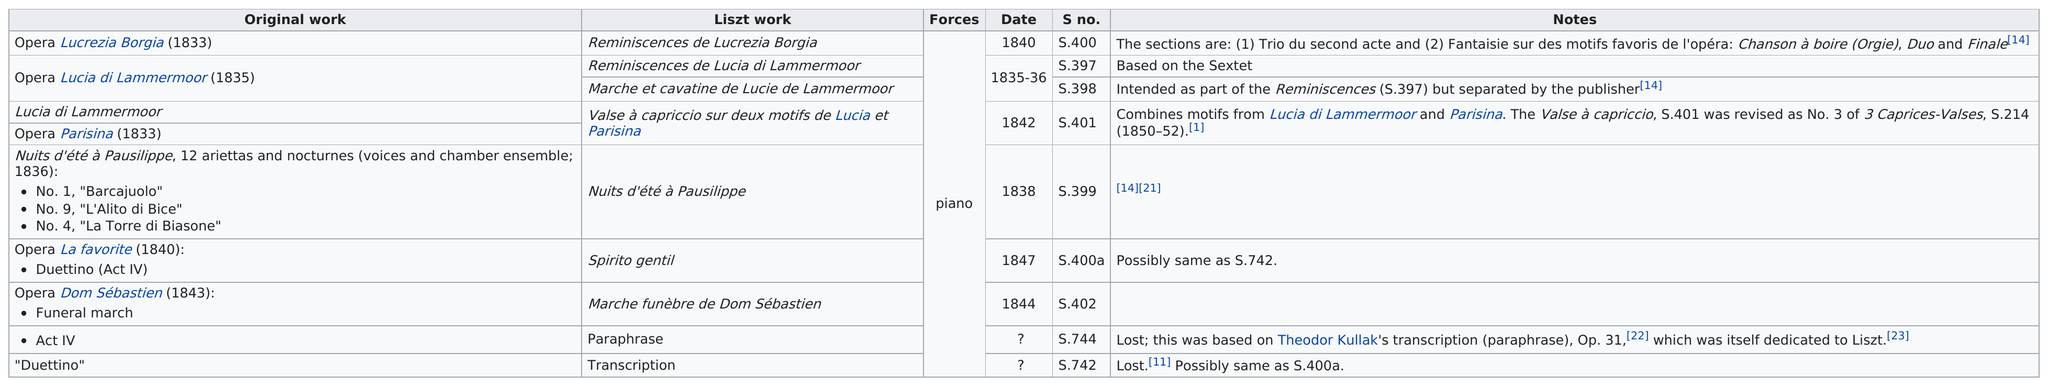Mention a couple of crucial points in this snapshot. In 1833, the first original work was published. Liszt used only the force of the piano to adapt the work of Gaetano Donizetti. After adapting the opera "Lucrezia Borgia," Gaetano Donizetti's "Lucia di Lammermoor" (1835) was adapted by Franz Liszt. Liszt adapted a total of 9 works from Gaetano Donizetti. There exists an opera that does not have a known date, such as the duettino... 